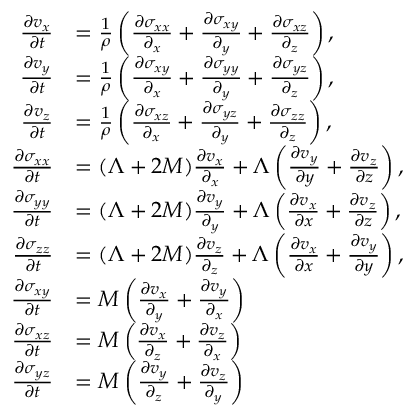Convert formula to latex. <formula><loc_0><loc_0><loc_500><loc_500>\begin{array} { r l } { \frac { \partial v _ { x } } { \partial t } } & { = \frac { 1 } { \rho } \left ( \frac { \partial \sigma _ { x x } } { \partial _ { x } } + \frac { \partial \sigma _ { x y } } { \partial _ { y } } + \frac { \partial \sigma _ { x z } } { \partial _ { z } } \right ) , } \\ { \frac { \partial v _ { y } } { \partial t } } & { = \frac { 1 } { \rho } \left ( \frac { \partial \sigma _ { x y } } { \partial _ { x } } + \frac { \partial \sigma _ { y y } } { \partial _ { y } } + \frac { \partial \sigma _ { y z } } { \partial _ { z } } \right ) , } \\ { \frac { \partial v _ { z } } { \partial t } } & { = \frac { 1 } { \rho } \left ( \frac { \partial \sigma _ { x z } } { \partial _ { x } } + \frac { \partial \sigma _ { y z } } { \partial _ { y } } + \frac { \partial \sigma _ { z z } } { \partial _ { z } } \right ) , } \\ { \frac { \partial \sigma _ { x x } } { \partial t } } & { = ( \Lambda + 2 M ) \frac { \partial v _ { x } } { \partial _ { x } } + \Lambda \left ( \frac { \partial v _ { y } } { \partial y } + \frac { \partial v _ { z } } { \partial z } \right ) , } \\ { \frac { \partial \sigma _ { y y } } { \partial t } } & { = ( \Lambda + 2 M ) \frac { \partial v _ { y } } { \partial _ { y } } + \Lambda \left ( \frac { \partial v _ { x } } { \partial x } + \frac { \partial v _ { z } } { \partial z } \right ) , } \\ { \frac { \partial \sigma _ { z z } } { \partial t } } & { = ( \Lambda + 2 M ) \frac { \partial v _ { z } } { \partial _ { z } } + \Lambda \left ( \frac { \partial v _ { x } } { \partial x } + \frac { \partial v _ { y } } { \partial y } \right ) , } \\ { \frac { \partial \sigma _ { x y } } { \partial t } } & { = M \left ( \frac { \partial v _ { x } } { \partial _ { y } } + \frac { \partial v _ { y } } { \partial _ { x } } \right ) } \\ { \frac { \partial \sigma _ { x z } } { \partial t } } & { = M \left ( \frac { \partial v _ { x } } { \partial _ { z } } + \frac { \partial v _ { z } } { \partial _ { x } } \right ) } \\ { \frac { \partial \sigma _ { y z } } { \partial t } } & { = M \left ( \frac { \partial v _ { y } } { \partial _ { z } } + \frac { \partial v _ { z } } { \partial _ { y } } \right ) } \end{array}</formula> 